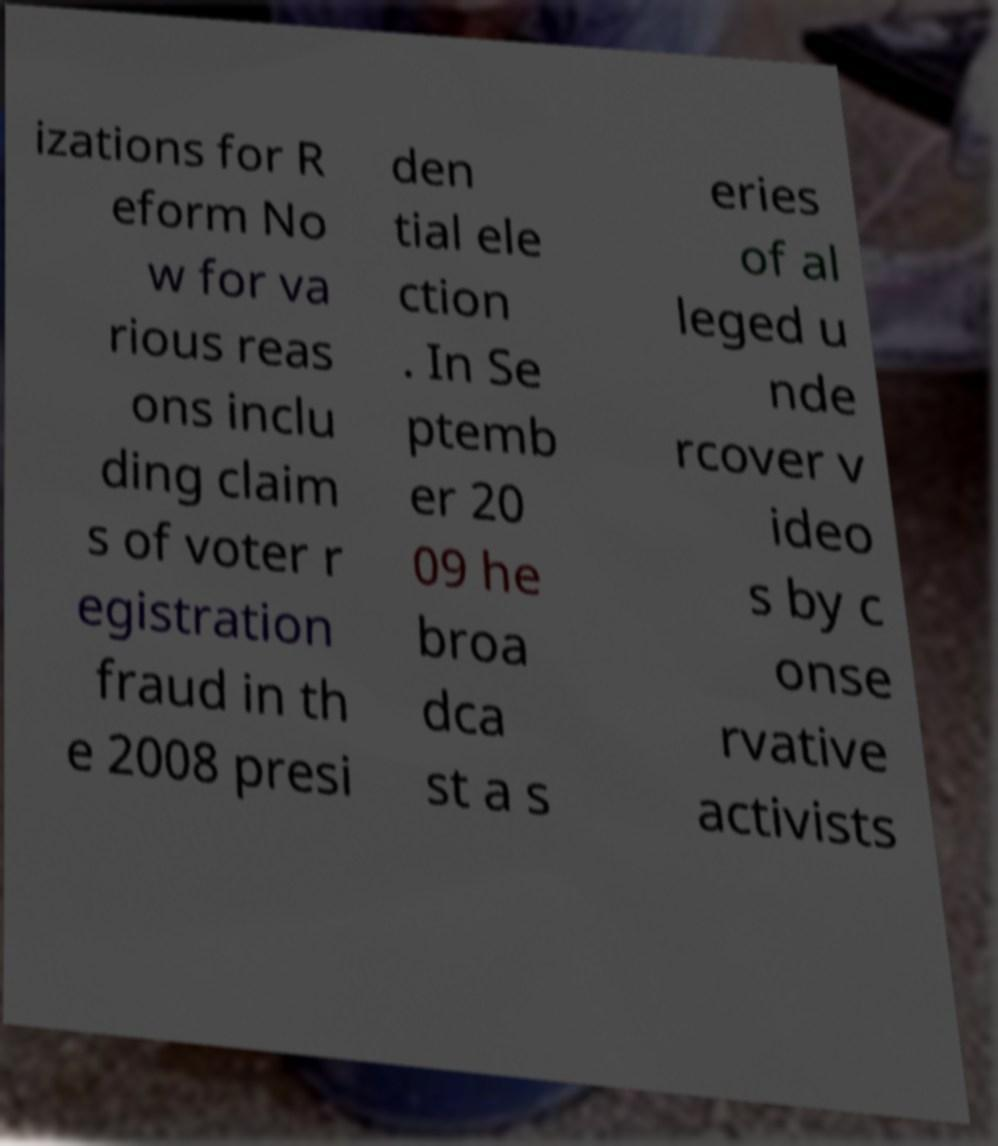Can you read and provide the text displayed in the image?This photo seems to have some interesting text. Can you extract and type it out for me? izations for R eform No w for va rious reas ons inclu ding claim s of voter r egistration fraud in th e 2008 presi den tial ele ction . In Se ptemb er 20 09 he broa dca st a s eries of al leged u nde rcover v ideo s by c onse rvative activists 